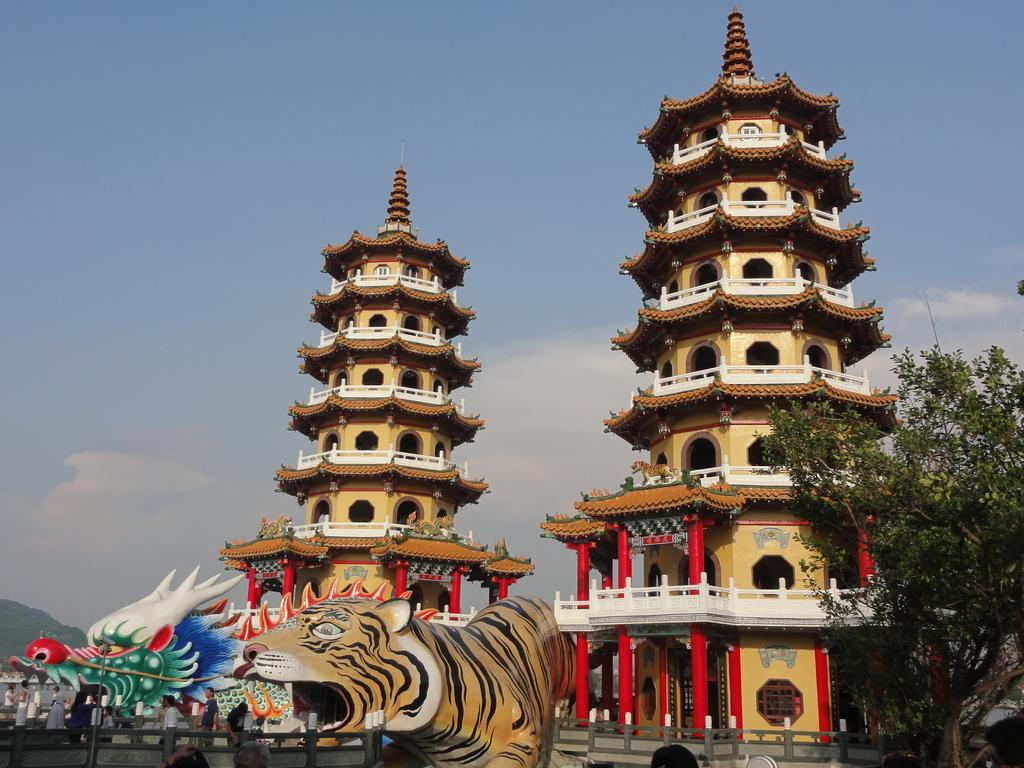What type of structures can be seen in the image? There are buildings in the image. What feature is common among the buildings? There are windows in the image. What type of barrier is present in the image? There is a fence in the image. What type of object can be seen in the image that is not a building or a fence? There is a toy animal in the image. What type of natural elements can be seen in the image? There are trees in the image. What part of the natural environment is visible in the image? The sky is visible in the image. How many sticks are being used for the action in the image? There are no sticks or actions involving sticks present in the image. What type of pocket can be seen in the image? There is no pocket visible in the image. 